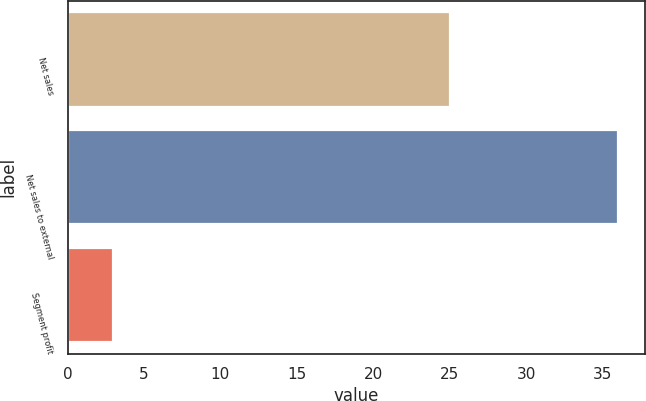<chart> <loc_0><loc_0><loc_500><loc_500><bar_chart><fcel>Net sales<fcel>Net sales to external<fcel>Segment profit<nl><fcel>25<fcel>36<fcel>3<nl></chart> 